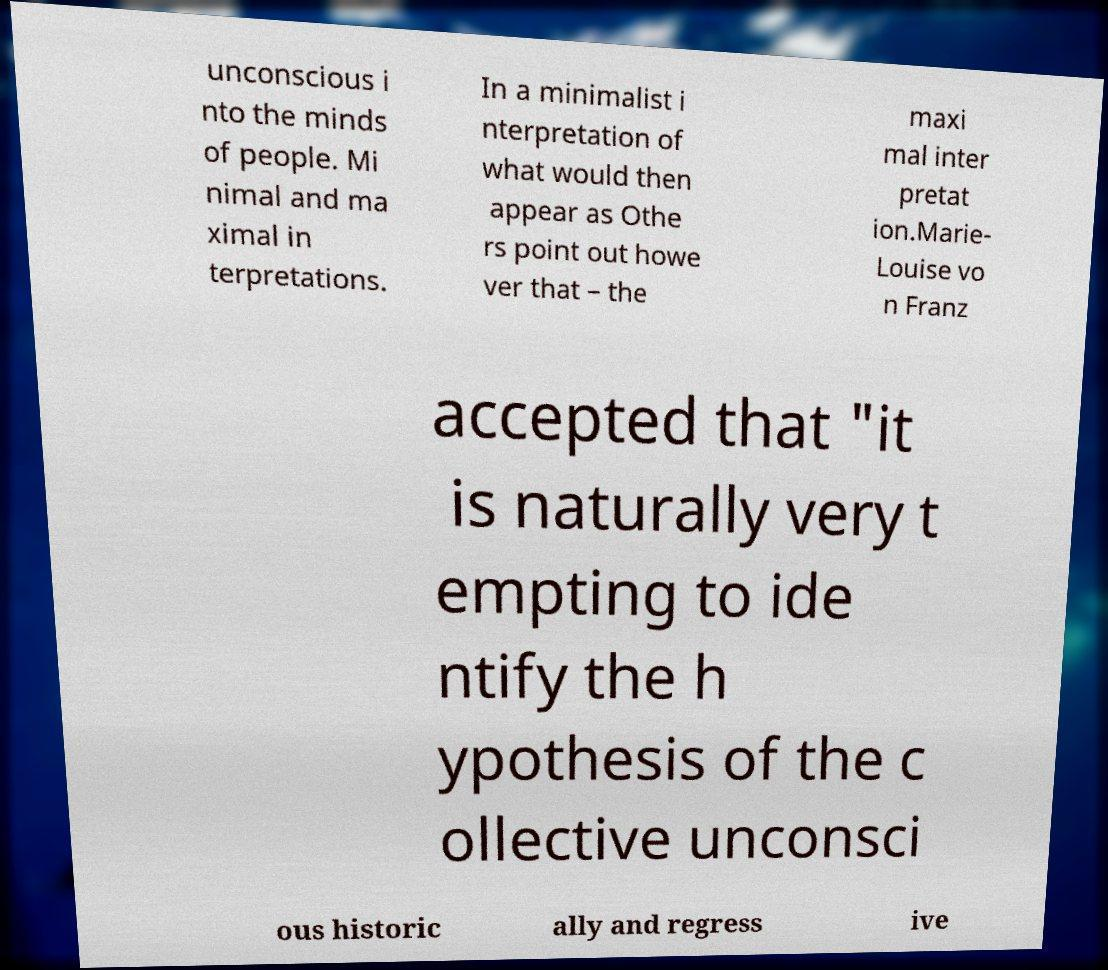Could you extract and type out the text from this image? unconscious i nto the minds of people. Mi nimal and ma ximal in terpretations. In a minimalist i nterpretation of what would then appear as Othe rs point out howe ver that – the maxi mal inter pretat ion.Marie- Louise vo n Franz accepted that "it is naturally very t empting to ide ntify the h ypothesis of the c ollective unconsci ous historic ally and regress ive 